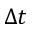Convert formula to latex. <formula><loc_0><loc_0><loc_500><loc_500>\Delta t</formula> 